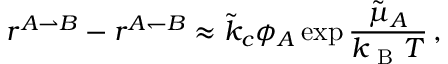<formula> <loc_0><loc_0><loc_500><loc_500>r ^ { A \rightharpoonup B } - r ^ { A \leftharpoondown B } \approx \tilde { k } _ { c } \phi _ { A } \exp { \frac { \tilde { \mu } _ { A } } { k _ { B } T } } \, ,</formula> 